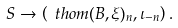Convert formula to latex. <formula><loc_0><loc_0><loc_500><loc_500>S \to \left ( \ t h o m ( B , \xi ) _ { n } , \iota _ { - n } \right ) .</formula> 